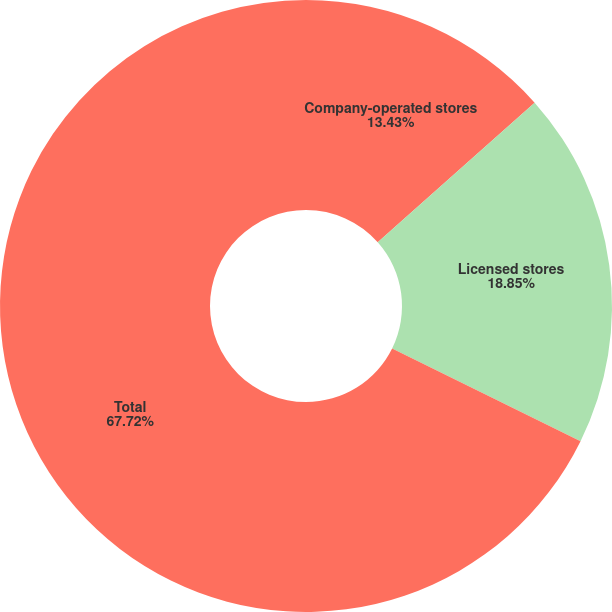Convert chart to OTSL. <chart><loc_0><loc_0><loc_500><loc_500><pie_chart><fcel>Company-operated stores<fcel>Licensed stores<fcel>Total<nl><fcel>13.43%<fcel>18.85%<fcel>67.72%<nl></chart> 